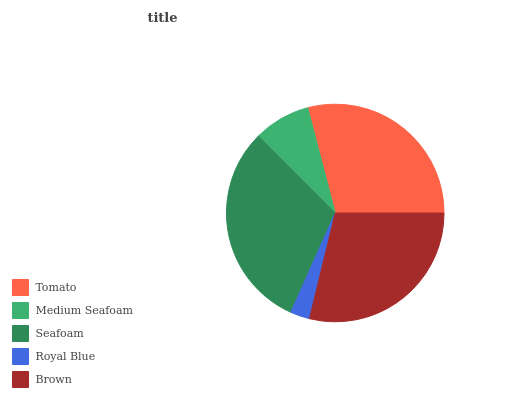Is Royal Blue the minimum?
Answer yes or no. Yes. Is Seafoam the maximum?
Answer yes or no. Yes. Is Medium Seafoam the minimum?
Answer yes or no. No. Is Medium Seafoam the maximum?
Answer yes or no. No. Is Tomato greater than Medium Seafoam?
Answer yes or no. Yes. Is Medium Seafoam less than Tomato?
Answer yes or no. Yes. Is Medium Seafoam greater than Tomato?
Answer yes or no. No. Is Tomato less than Medium Seafoam?
Answer yes or no. No. Is Brown the high median?
Answer yes or no. Yes. Is Brown the low median?
Answer yes or no. Yes. Is Royal Blue the high median?
Answer yes or no. No. Is Medium Seafoam the low median?
Answer yes or no. No. 